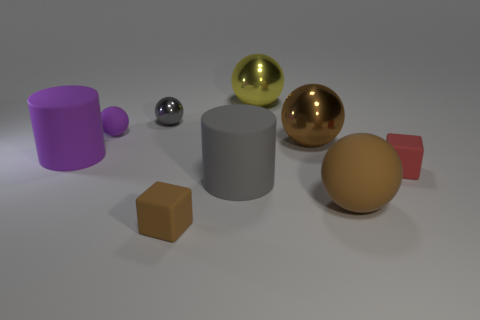Subtract all purple spheres. How many spheres are left? 4 Subtract 1 blocks. How many blocks are left? 1 Add 1 cyan metal objects. How many objects exist? 10 Subtract all yellow spheres. How many spheres are left? 4 Subtract all cubes. How many objects are left? 7 Subtract all blue cubes. Subtract all cyan cylinders. How many cubes are left? 2 Subtract all brown cubes. How many purple spheres are left? 1 Subtract all shiny objects. Subtract all large brown things. How many objects are left? 4 Add 7 brown metallic objects. How many brown metallic objects are left? 8 Add 6 blue metallic objects. How many blue metallic objects exist? 6 